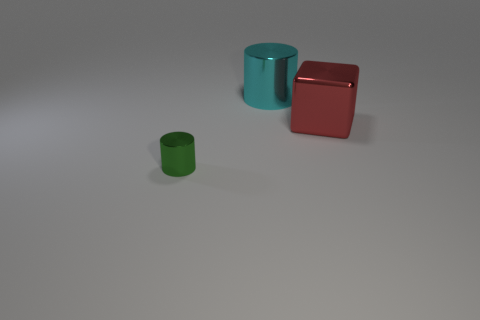How many tiny things are either blue metallic spheres or metal cubes?
Give a very brief answer. 0. Are there fewer large metal objects than tiny shiny cylinders?
Offer a very short reply. No. Is there anything else that has the same size as the red thing?
Your answer should be compact. Yes. Are there more metallic objects than tiny purple blocks?
Provide a short and direct response. Yes. There is a shiny cylinder behind the tiny green metal thing; what number of big metallic cubes are in front of it?
Your answer should be compact. 1. Are there any green metallic cylinders left of the big red block?
Your answer should be very brief. Yes. There is a object that is behind the big metal object right of the big cyan shiny cylinder; what is its shape?
Give a very brief answer. Cylinder. Are there fewer big red metal cubes that are to the left of the cyan shiny object than metal things that are on the right side of the small metal cylinder?
Provide a short and direct response. Yes. What is the color of the other thing that is the same shape as the cyan metal object?
Make the answer very short. Green. How many metallic objects are both behind the green cylinder and on the left side of the red block?
Offer a very short reply. 1. 